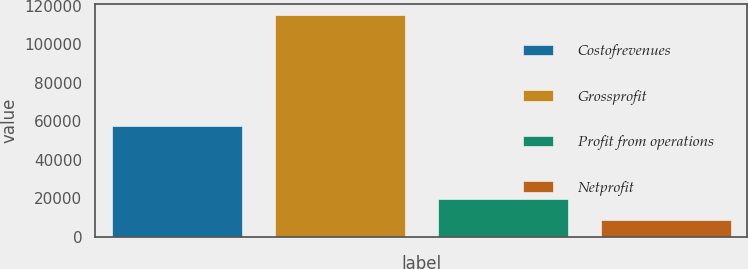<chart> <loc_0><loc_0><loc_500><loc_500><bar_chart><fcel>Costofrevenues<fcel>Grossprofit<fcel>Profit from operations<fcel>Netprofit<nl><fcel>57526<fcel>115304<fcel>19421.6<fcel>8768<nl></chart> 